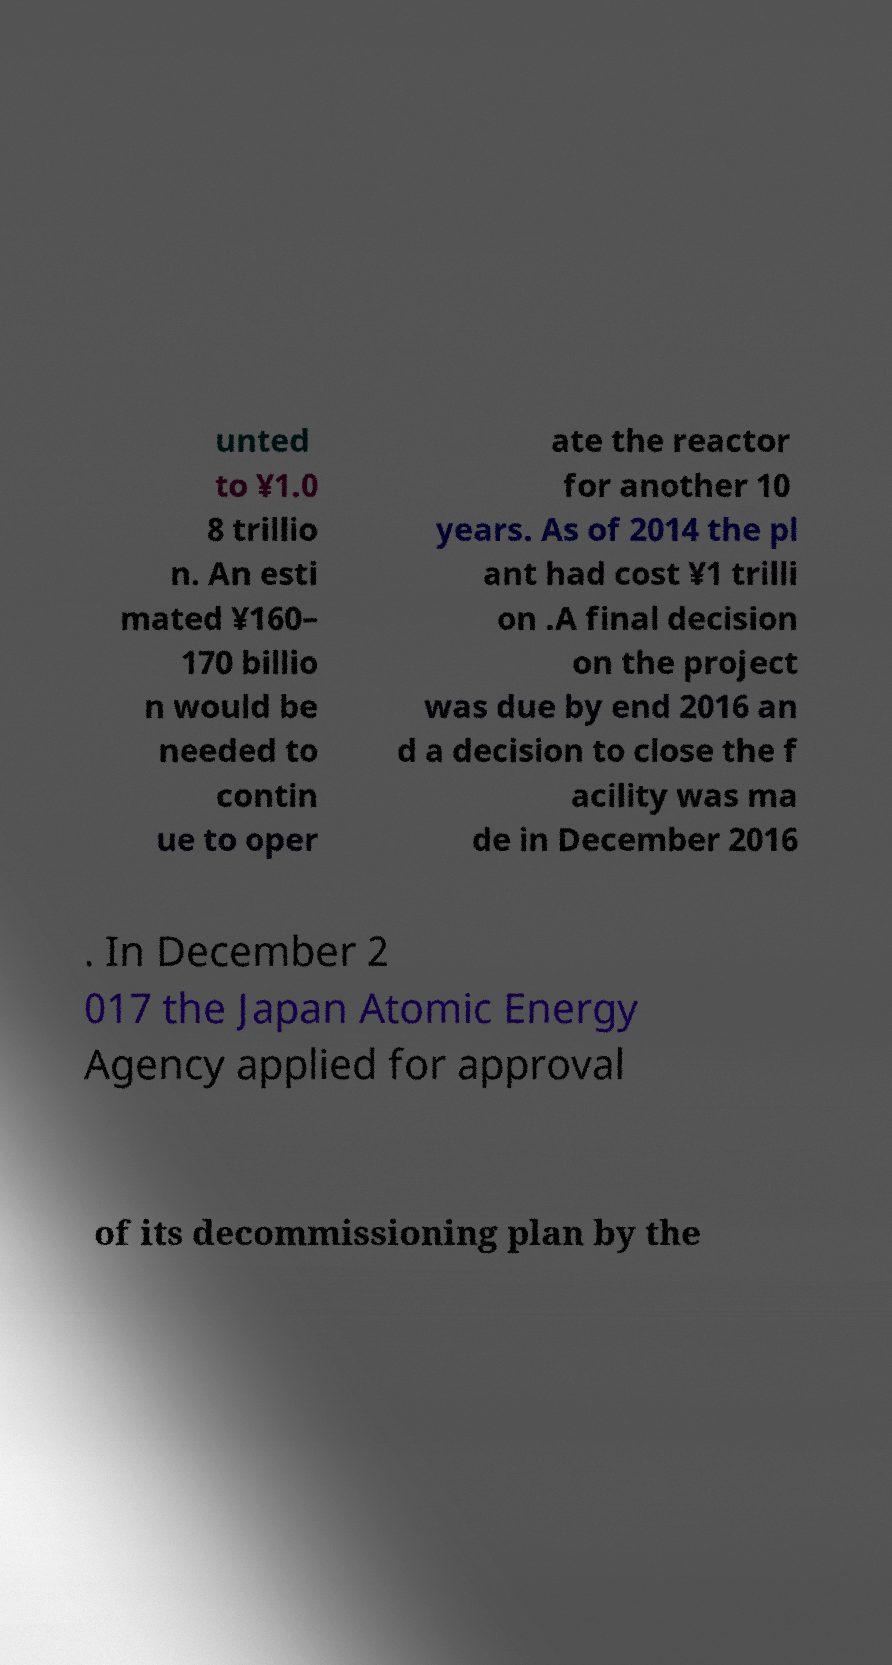Could you assist in decoding the text presented in this image and type it out clearly? unted to ¥1.0 8 trillio n. An esti mated ¥160– 170 billio n would be needed to contin ue to oper ate the reactor for another 10 years. As of 2014 the pl ant had cost ¥1 trilli on .A final decision on the project was due by end 2016 an d a decision to close the f acility was ma de in December 2016 . In December 2 017 the Japan Atomic Energy Agency applied for approval of its decommissioning plan by the 